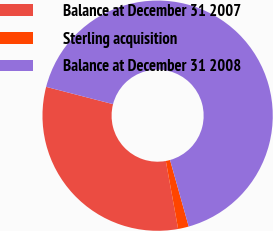Convert chart to OTSL. <chart><loc_0><loc_0><loc_500><loc_500><pie_chart><fcel>Balance at December 31 2007<fcel>Sterling acquisition<fcel>Balance at December 31 2008<nl><fcel>31.88%<fcel>1.5%<fcel>66.62%<nl></chart> 